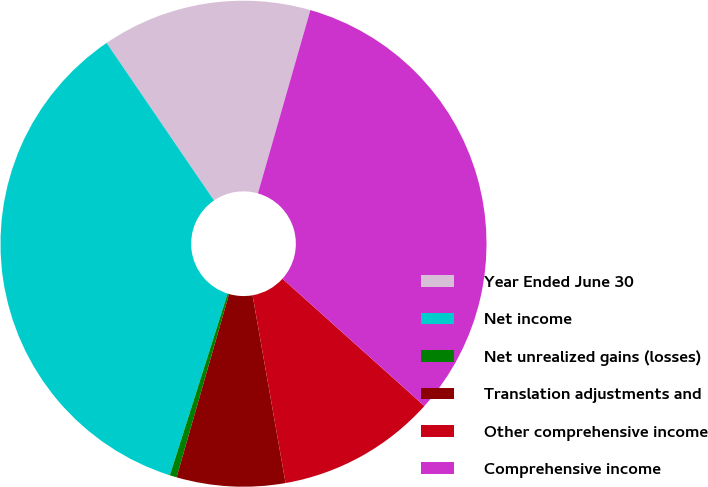<chart> <loc_0><loc_0><loc_500><loc_500><pie_chart><fcel>Year Ended June 30<fcel>Net income<fcel>Net unrealized gains (losses)<fcel>Translation adjustments and<fcel>Other comprehensive income<fcel>Comprehensive income<nl><fcel>13.96%<fcel>35.57%<fcel>0.46%<fcel>7.21%<fcel>10.59%<fcel>32.2%<nl></chart> 